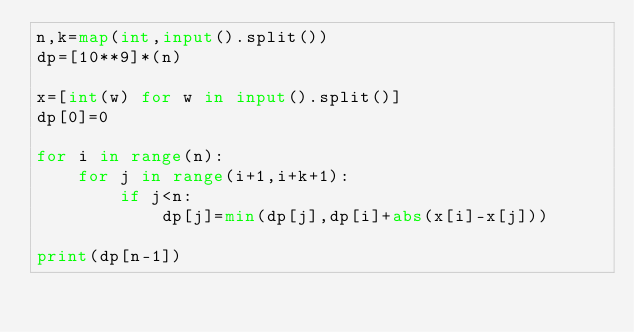Convert code to text. <code><loc_0><loc_0><loc_500><loc_500><_Python_>n,k=map(int,input().split())
dp=[10**9]*(n)

x=[int(w) for w in input().split()]
dp[0]=0

for i in range(n):
    for j in range(i+1,i+k+1):
        if j<n:
            dp[j]=min(dp[j],dp[i]+abs(x[i]-x[j]))

print(dp[n-1])</code> 